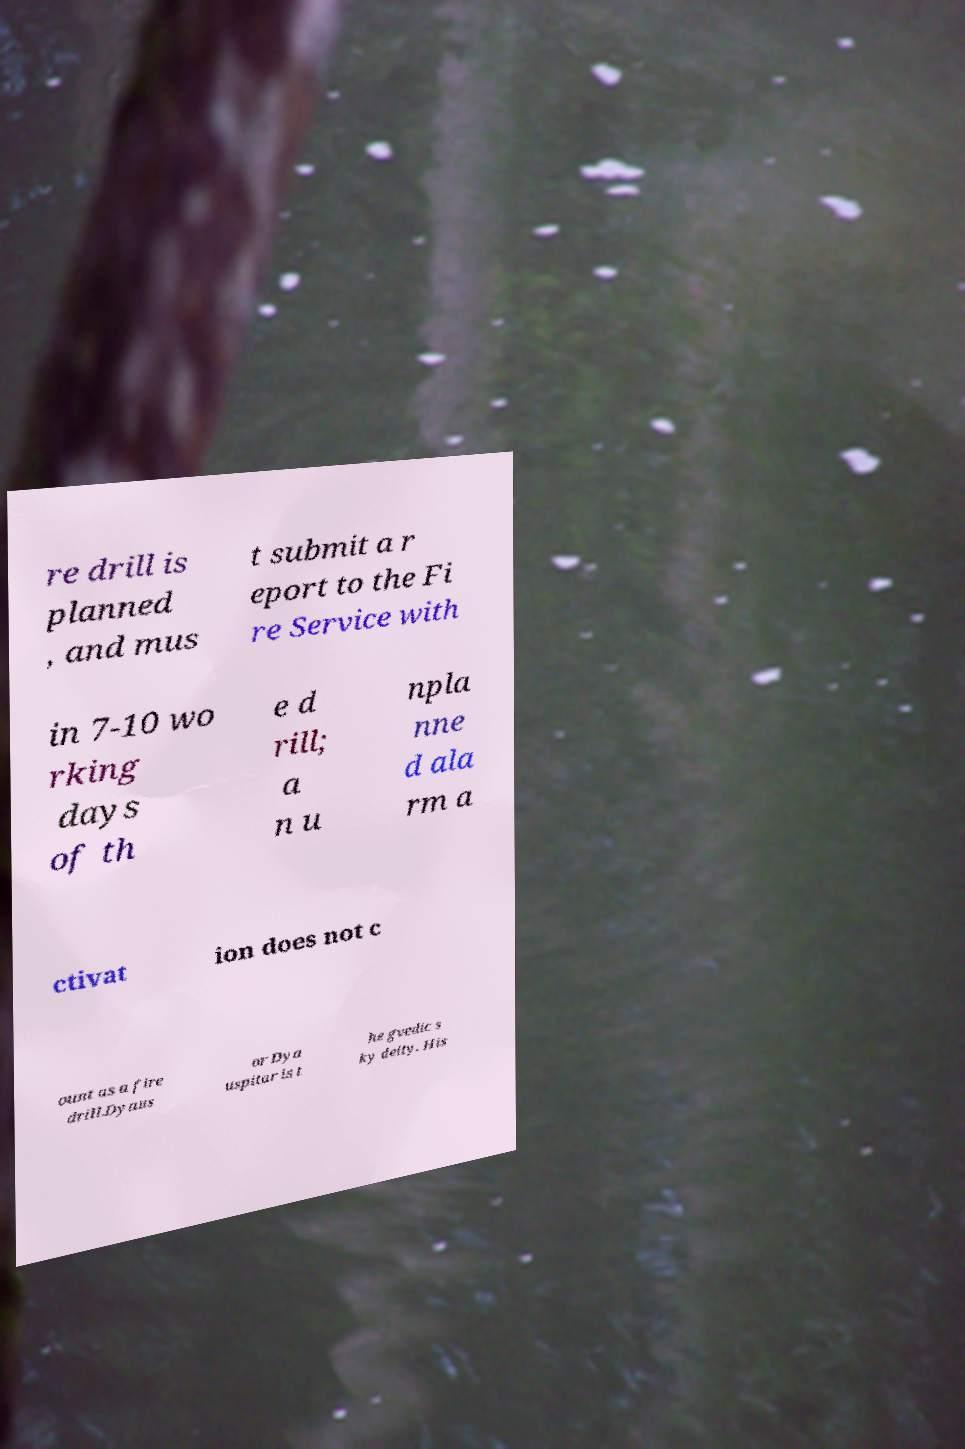I need the written content from this picture converted into text. Can you do that? re drill is planned , and mus t submit a r eport to the Fi re Service with in 7-10 wo rking days of th e d rill; a n u npla nne d ala rm a ctivat ion does not c ount as a fire drill.Dyaus or Dya uspitar is t he gvedic s ky deity. His 